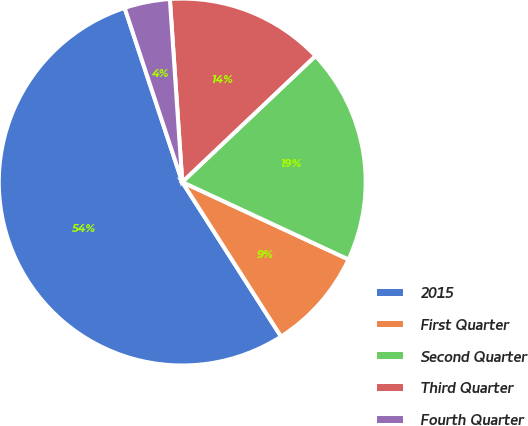Convert chart. <chart><loc_0><loc_0><loc_500><loc_500><pie_chart><fcel>2015<fcel>First Quarter<fcel>Second Quarter<fcel>Third Quarter<fcel>Fourth Quarter<nl><fcel>53.97%<fcel>9.01%<fcel>19.0%<fcel>14.01%<fcel>4.01%<nl></chart> 